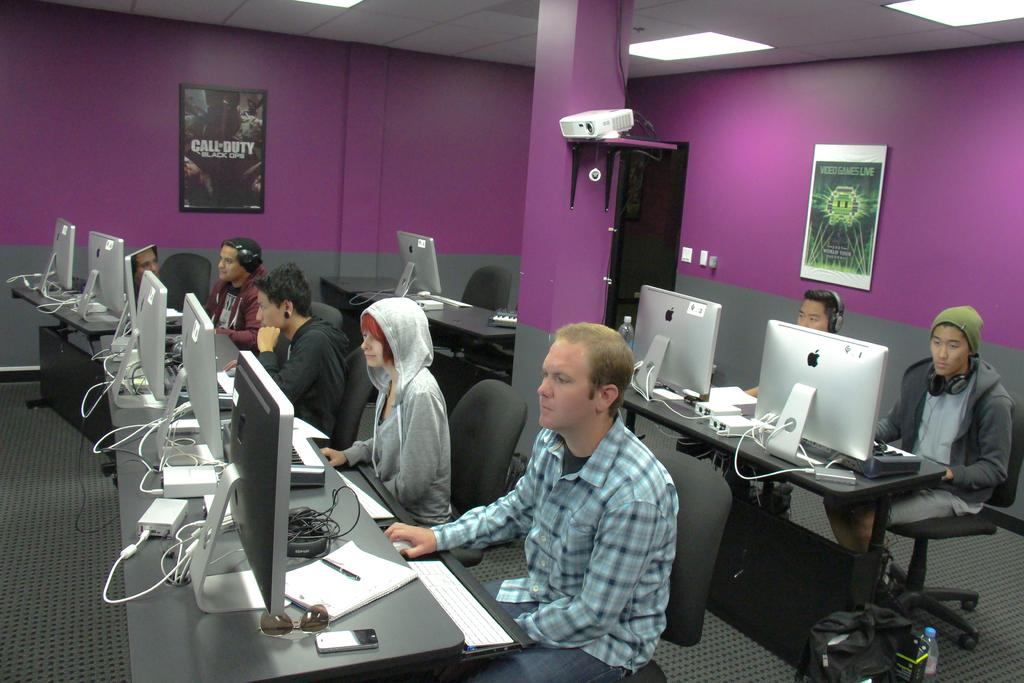<image>
Relay a brief, clear account of the picture shown. Several people work on computers in an office with a Call of Duty poster hanging on the wall. 